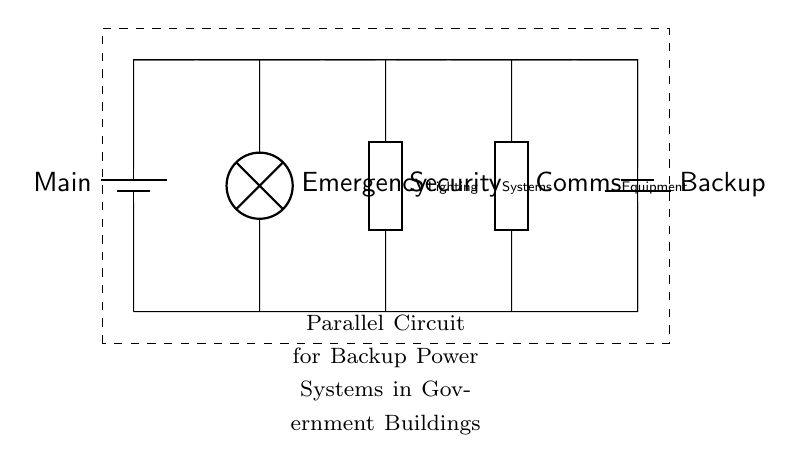What is the main power source in this circuit? The main power source is labeled as "Main," which indicates it is the primary battery supplying power.
Answer: Main What devices are powered in this backup circuit? The devices powered include emergency lighting, security systems, and communications equipment, all visually represented as components connected in parallel.
Answer: Emergency lighting, Security systems, Communications equipment How many batteries are depicted in the circuit? There are two batteries shown in the circuit diagram; one is the main and the other is the backup.
Answer: 2 What kind of circuit type is displayed? The circuit is a parallel circuit, as evidenced by the multiple branches that provide power to different devices simultaneously without affecting each other's operation.
Answer: Parallel How does the backup battery connect to the circuit? The backup battery connects in parallel to the main battery, allowing it to supply power alongside the main source without interrupting the supply to other devices.
Answer: In parallel What happens if the main power source fails? If the main power source fails, the backup battery will continue to supply power to all connected devices, ensuring uninterrupted operation.
Answer: Uninterrupted operation 